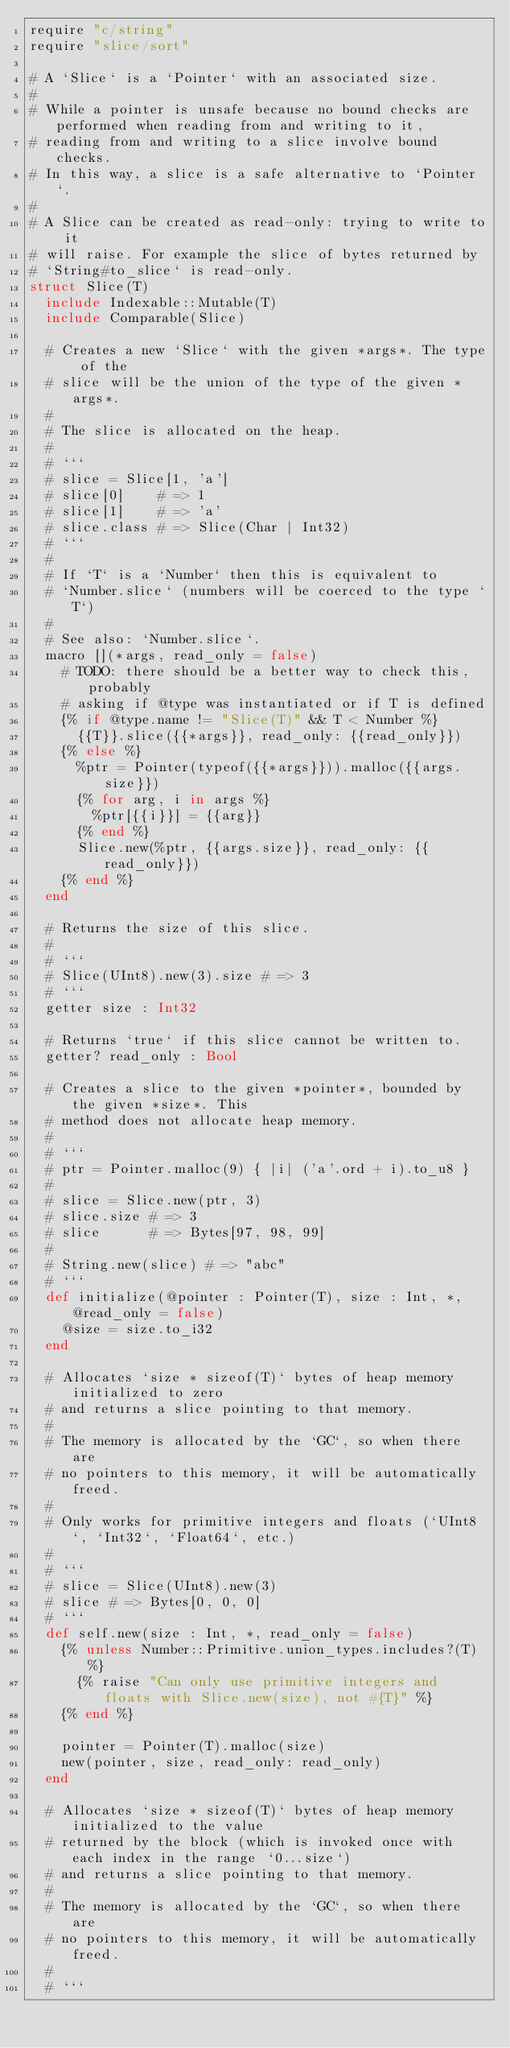Convert code to text. <code><loc_0><loc_0><loc_500><loc_500><_Crystal_>require "c/string"
require "slice/sort"

# A `Slice` is a `Pointer` with an associated size.
#
# While a pointer is unsafe because no bound checks are performed when reading from and writing to it,
# reading from and writing to a slice involve bound checks.
# In this way, a slice is a safe alternative to `Pointer`.
#
# A Slice can be created as read-only: trying to write to it
# will raise. For example the slice of bytes returned by
# `String#to_slice` is read-only.
struct Slice(T)
  include Indexable::Mutable(T)
  include Comparable(Slice)

  # Creates a new `Slice` with the given *args*. The type of the
  # slice will be the union of the type of the given *args*.
  #
  # The slice is allocated on the heap.
  #
  # ```
  # slice = Slice[1, 'a']
  # slice[0]    # => 1
  # slice[1]    # => 'a'
  # slice.class # => Slice(Char | Int32)
  # ```
  #
  # If `T` is a `Number` then this is equivalent to
  # `Number.slice` (numbers will be coerced to the type `T`)
  #
  # See also: `Number.slice`.
  macro [](*args, read_only = false)
    # TODO: there should be a better way to check this, probably
    # asking if @type was instantiated or if T is defined
    {% if @type.name != "Slice(T)" && T < Number %}
      {{T}}.slice({{*args}}, read_only: {{read_only}})
    {% else %}
      %ptr = Pointer(typeof({{*args}})).malloc({{args.size}})
      {% for arg, i in args %}
        %ptr[{{i}}] = {{arg}}
      {% end %}
      Slice.new(%ptr, {{args.size}}, read_only: {{read_only}})
    {% end %}
  end

  # Returns the size of this slice.
  #
  # ```
  # Slice(UInt8).new(3).size # => 3
  # ```
  getter size : Int32

  # Returns `true` if this slice cannot be written to.
  getter? read_only : Bool

  # Creates a slice to the given *pointer*, bounded by the given *size*. This
  # method does not allocate heap memory.
  #
  # ```
  # ptr = Pointer.malloc(9) { |i| ('a'.ord + i).to_u8 }
  #
  # slice = Slice.new(ptr, 3)
  # slice.size # => 3
  # slice      # => Bytes[97, 98, 99]
  #
  # String.new(slice) # => "abc"
  # ```
  def initialize(@pointer : Pointer(T), size : Int, *, @read_only = false)
    @size = size.to_i32
  end

  # Allocates `size * sizeof(T)` bytes of heap memory initialized to zero
  # and returns a slice pointing to that memory.
  #
  # The memory is allocated by the `GC`, so when there are
  # no pointers to this memory, it will be automatically freed.
  #
  # Only works for primitive integers and floats (`UInt8`, `Int32`, `Float64`, etc.)
  #
  # ```
  # slice = Slice(UInt8).new(3)
  # slice # => Bytes[0, 0, 0]
  # ```
  def self.new(size : Int, *, read_only = false)
    {% unless Number::Primitive.union_types.includes?(T) %}
      {% raise "Can only use primitive integers and floats with Slice.new(size), not #{T}" %}
    {% end %}

    pointer = Pointer(T).malloc(size)
    new(pointer, size, read_only: read_only)
  end

  # Allocates `size * sizeof(T)` bytes of heap memory initialized to the value
  # returned by the block (which is invoked once with each index in the range `0...size`)
  # and returns a slice pointing to that memory.
  #
  # The memory is allocated by the `GC`, so when there are
  # no pointers to this memory, it will be automatically freed.
  #
  # ```</code> 